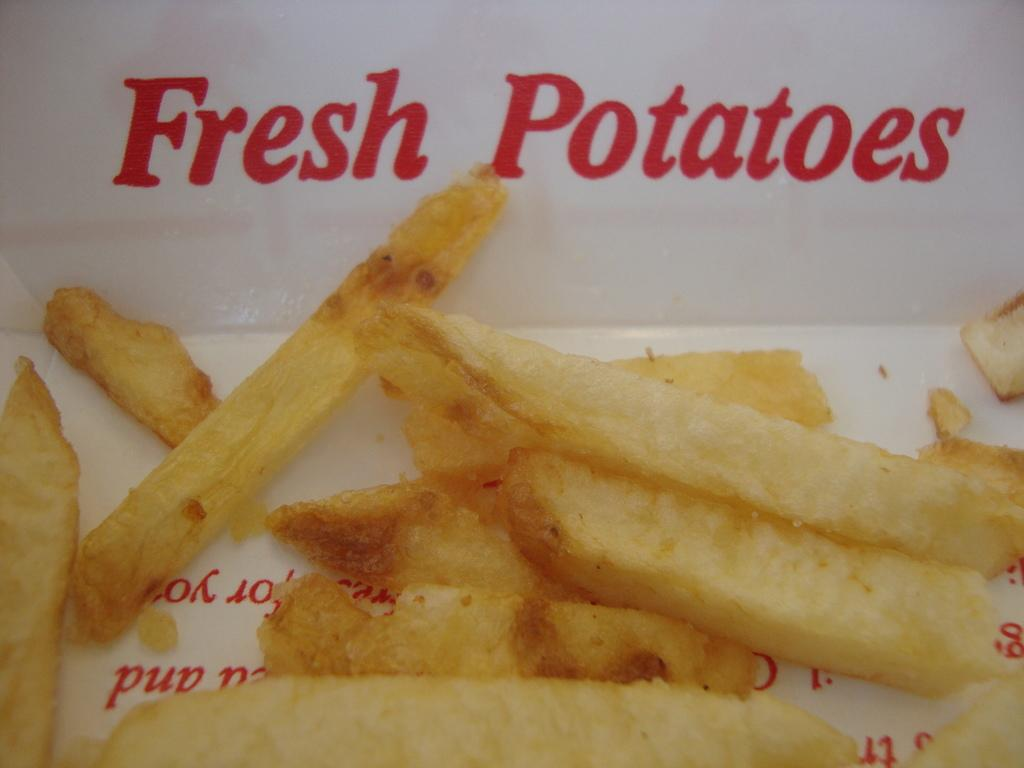What types of food items can be seen in the image? There are food items in the image, but their specific types cannot be determined without more information. Can you describe the white object with writing on it? The white object with writing on it is likely a label or packaging for one of the food items. How many ladybugs can be seen crawling on the food items in the image? There are no ladybugs present in the image; it only features food items and a white object with writing on it. 